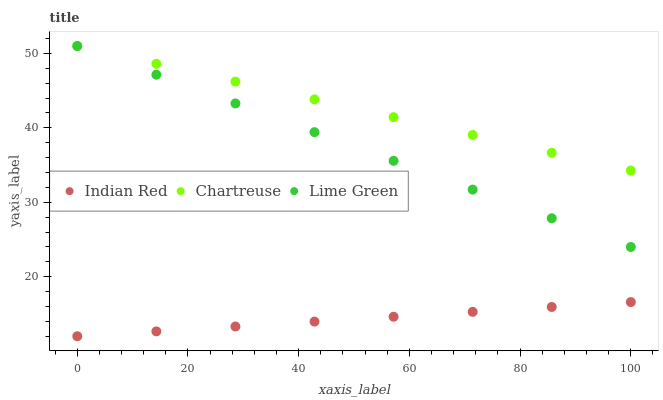Does Indian Red have the minimum area under the curve?
Answer yes or no. Yes. Does Chartreuse have the maximum area under the curve?
Answer yes or no. Yes. Does Lime Green have the minimum area under the curve?
Answer yes or no. No. Does Lime Green have the maximum area under the curve?
Answer yes or no. No. Is Indian Red the smoothest?
Answer yes or no. Yes. Is Chartreuse the roughest?
Answer yes or no. Yes. Is Lime Green the smoothest?
Answer yes or no. No. Is Lime Green the roughest?
Answer yes or no. No. Does Indian Red have the lowest value?
Answer yes or no. Yes. Does Lime Green have the lowest value?
Answer yes or no. No. Does Lime Green have the highest value?
Answer yes or no. Yes. Does Indian Red have the highest value?
Answer yes or no. No. Is Indian Red less than Lime Green?
Answer yes or no. Yes. Is Chartreuse greater than Indian Red?
Answer yes or no. Yes. Does Chartreuse intersect Lime Green?
Answer yes or no. Yes. Is Chartreuse less than Lime Green?
Answer yes or no. No. Is Chartreuse greater than Lime Green?
Answer yes or no. No. Does Indian Red intersect Lime Green?
Answer yes or no. No. 